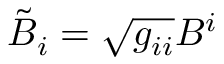Convert formula to latex. <formula><loc_0><loc_0><loc_500><loc_500>\tilde { B } _ { i } = \sqrt { g _ { i i } } B ^ { i }</formula> 